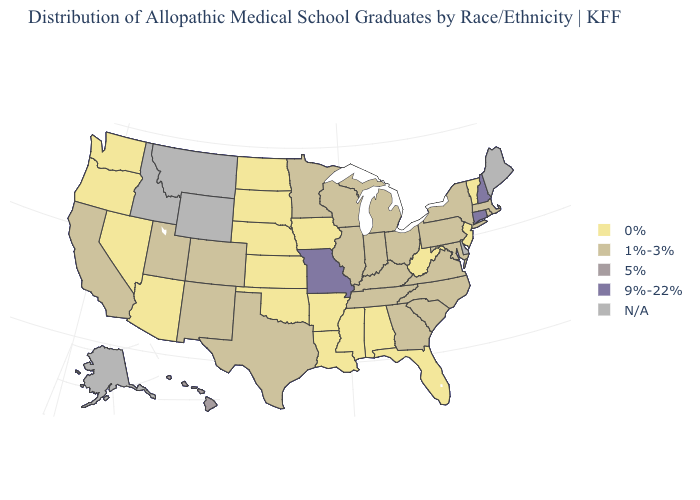What is the value of Rhode Island?
Give a very brief answer. 1%-3%. Does the map have missing data?
Concise answer only. Yes. What is the highest value in the USA?
Quick response, please. 9%-22%. Name the states that have a value in the range N/A?
Short answer required. Alaska, Delaware, Idaho, Maine, Montana, Wyoming. Does West Virginia have the lowest value in the USA?
Short answer required. Yes. Is the legend a continuous bar?
Be succinct. No. Name the states that have a value in the range 5%?
Answer briefly. Hawaii. Among the states that border Wyoming , which have the lowest value?
Answer briefly. Nebraska, South Dakota. Does Missouri have the highest value in the USA?
Be succinct. Yes. What is the lowest value in the USA?
Be succinct. 0%. Among the states that border South Carolina , which have the highest value?
Be succinct. Georgia, North Carolina. Among the states that border Georgia , does Florida have the lowest value?
Keep it brief. Yes. What is the highest value in states that border Illinois?
Answer briefly. 9%-22%. Name the states that have a value in the range 5%?
Give a very brief answer. Hawaii. 